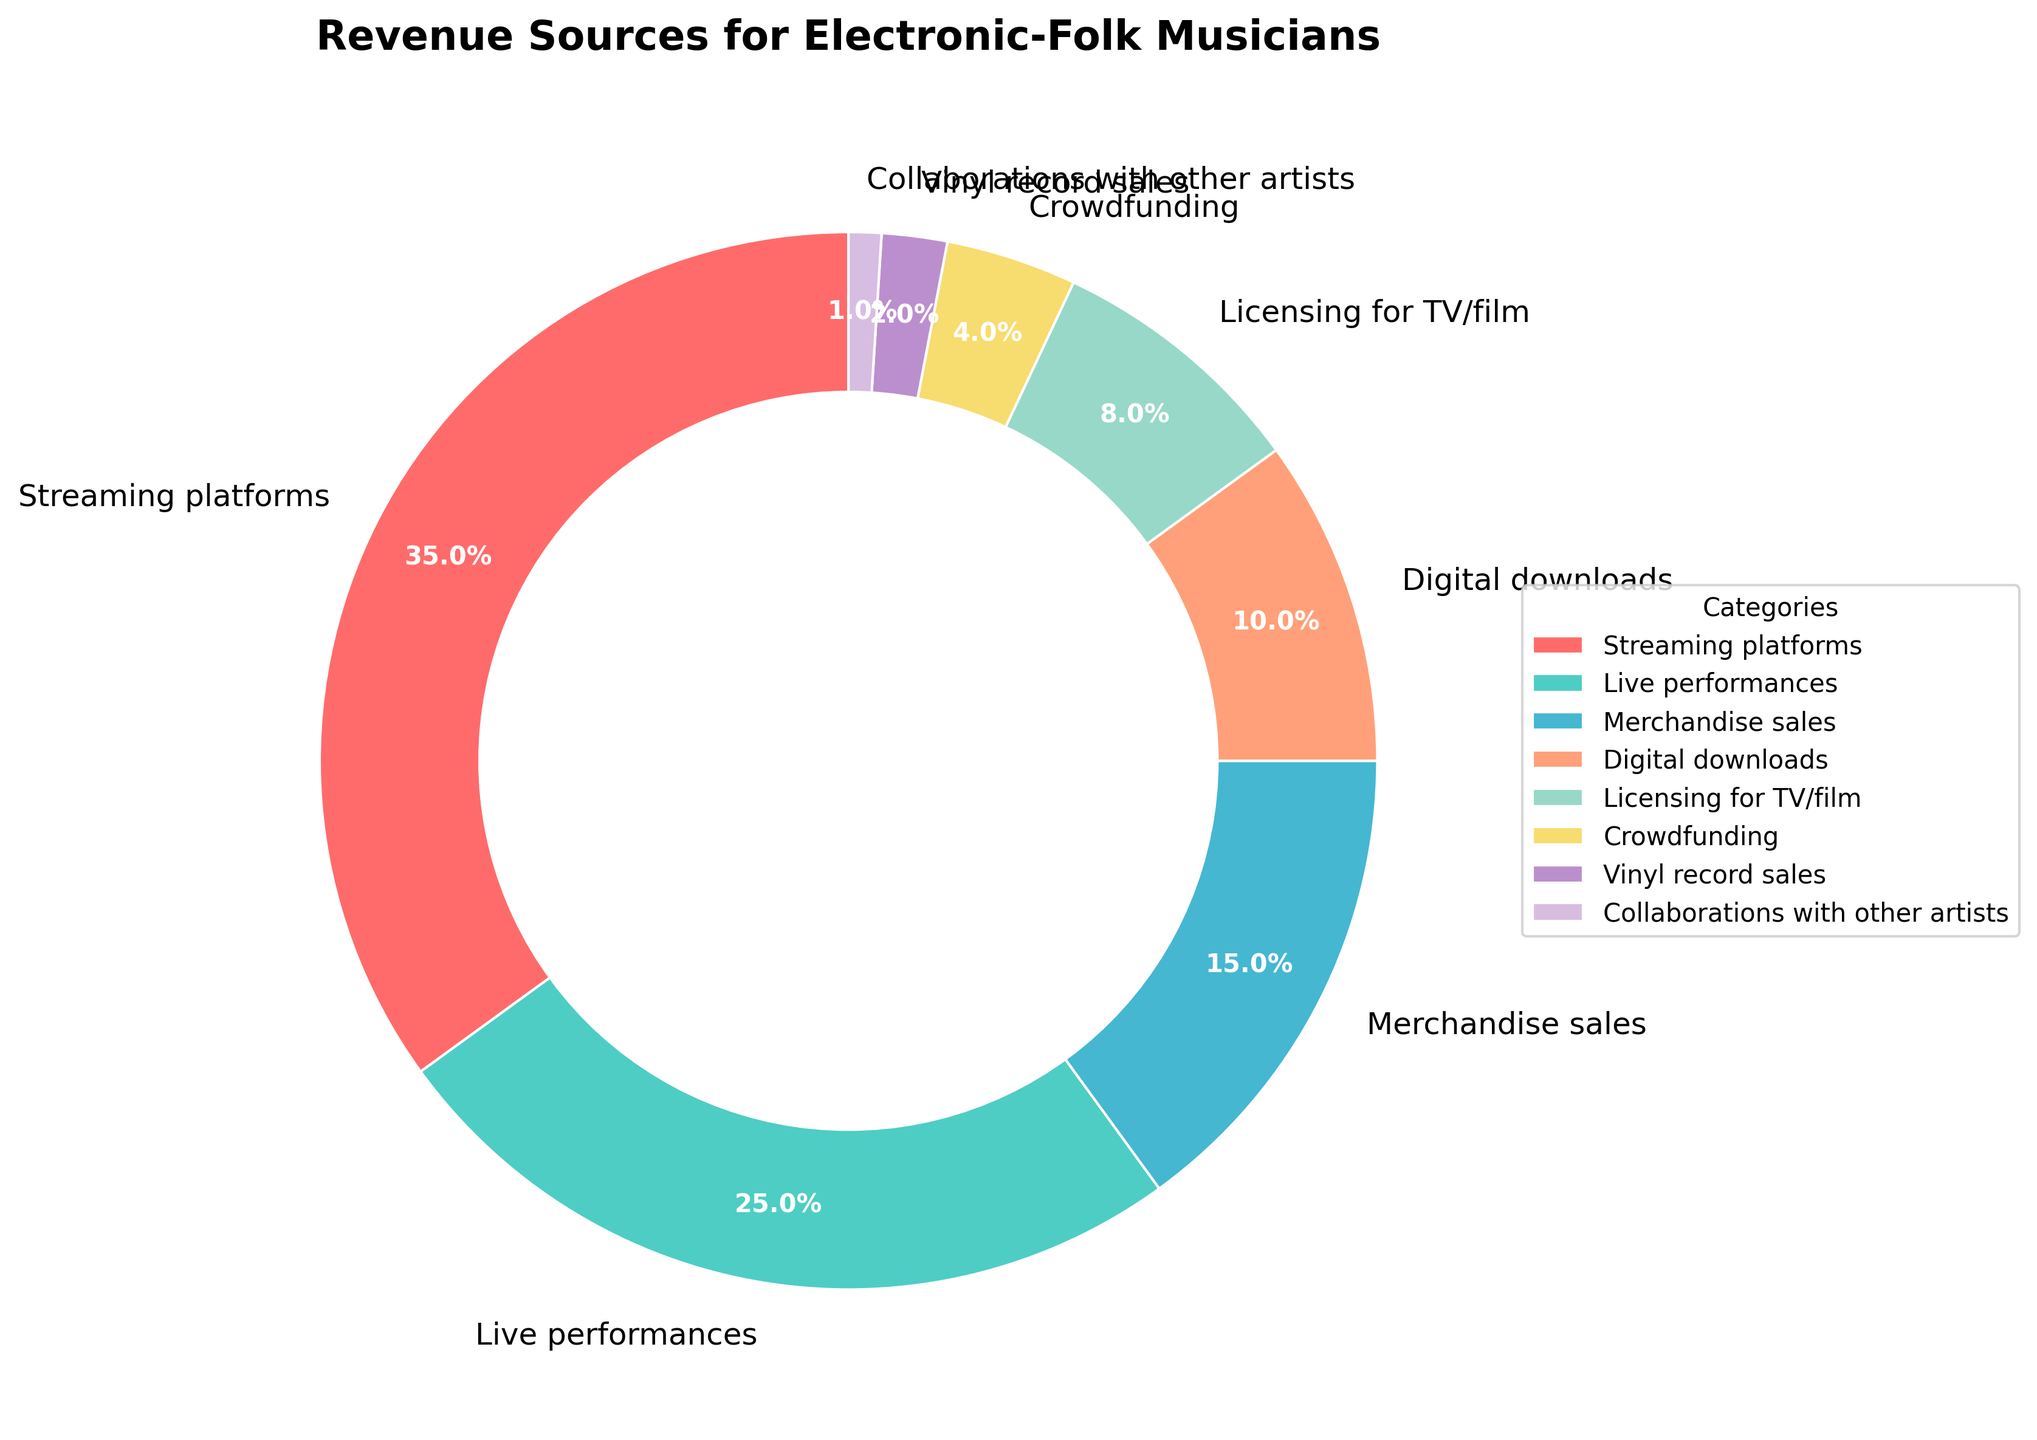Which category generates the highest revenue for electronic-folk musicians? The highest revenue percentage can be directly observed from the figure, which is labeled and shaded accordingly.
Answer: Streaming platforms Which category contributes the least to the revenue for electronic-folk musicians? The smallest revenue percentage can be directly observed from the figure, which is labeled and shaded accordingly.
Answer: Collaborations with other artists What is the combined revenue percentage from live performances and merchandise sales? Sum the percentages of live performances (25%) and merchandise sales (15%). 25% + 15% = 40%
Answer: 40% How does the revenue from live performances compare to digital downloads? Compare the percentages of live performances (25%) and digital downloads (10%). 25% is greater than 10%.
Answer: Live performances generate more revenue What's the difference in revenue percentage between streaming platforms and vinyl record sales? Subtract the percentage of vinyl record sales (2%) from the percentage of streaming platforms (35%). 35% - 2% = 33%
Answer: 33% What is the total revenue percentage for digital downloads and licensing for TV/film combined? Sum the percentages of digital downloads (10%) and licensing for TV/film (8%). 10% + 8% = 18%
Answer: 18% What is the revenue contribution from the categories that contribute less than 10% individually? Add the percentages of categories with less than 10% (licensing for TV/film 8%, crowdfunding 4%, vinyl record sales 2%, collaborations with other artists 1%). 8% + 4% + 2% + 1% = 15%
Answer: 15% What is the sum of the revenue percentages from live performances and merchandise sales? Add the percentages of live performances (25%) and merchandise sales (15%). 25% + 15% = 40%
Answer: 40% Of the categories with revenue percentages greater than 20%, which one has the second-highest revenue? The categories with more than 20% are streaming platforms (35%) and live performances (25%). The second-highest among these is live performances (25%).
Answer: Live performances What percentage of revenue is generated from crowdfunding and collaborations with other artists combined? Add the percentages of crowdfunding (4%) and collaborations with other artists (1%). 4% + 1% = 5%
Answer: 5% 